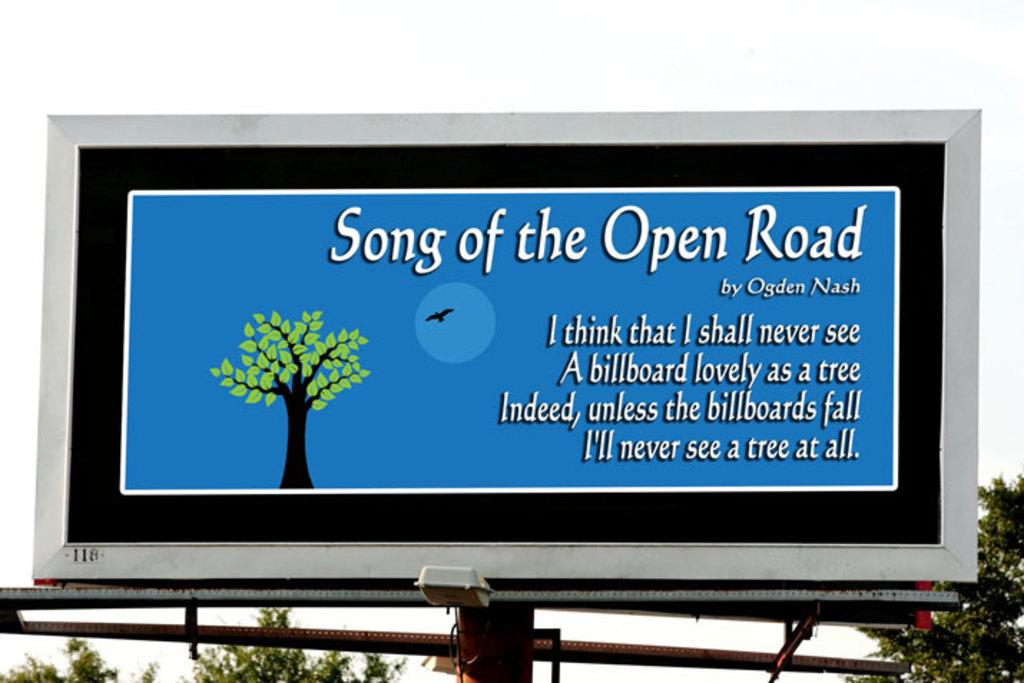<image>
Summarize the visual content of the image. A billboard has the lyrics to Song of the Open Road by Ogden Nash written on it 